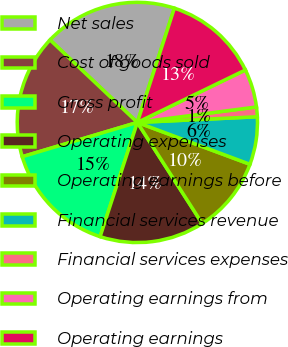<chart> <loc_0><loc_0><loc_500><loc_500><pie_chart><fcel>Net sales<fcel>Cost of goods sold<fcel>Gross profit<fcel>Operating expenses<fcel>Operating earnings before<fcel>Financial services revenue<fcel>Financial services expenses<fcel>Operating earnings from<fcel>Operating earnings<nl><fcel>17.94%<fcel>16.66%<fcel>15.38%<fcel>14.1%<fcel>10.26%<fcel>6.42%<fcel>1.3%<fcel>5.14%<fcel>12.82%<nl></chart> 